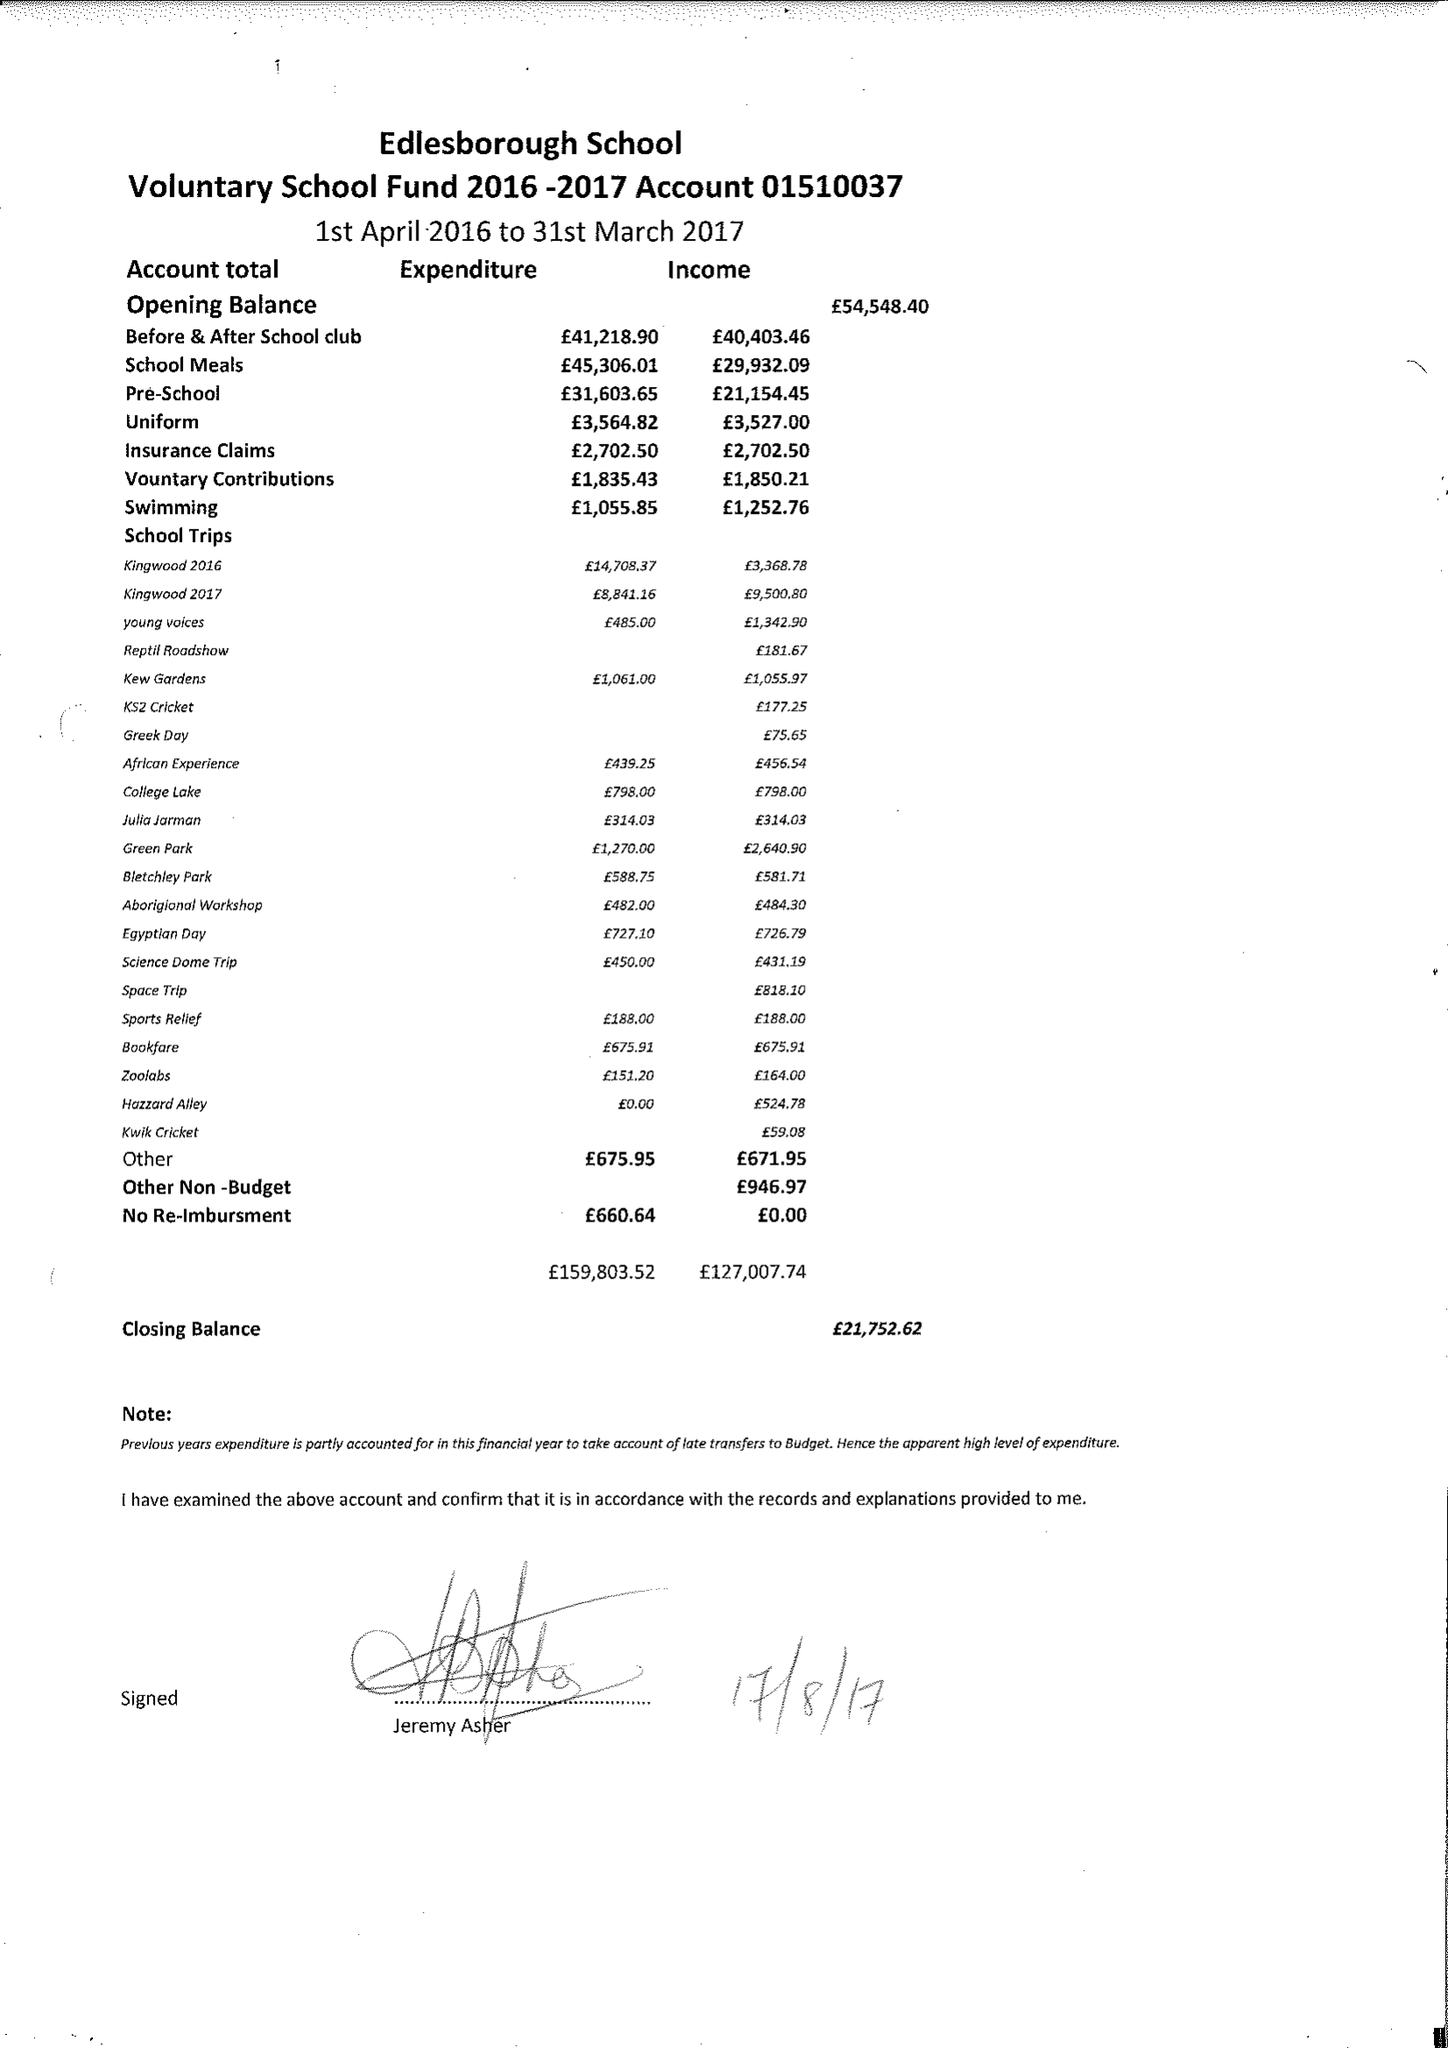What is the value for the report_date?
Answer the question using a single word or phrase. 2017-03-31 